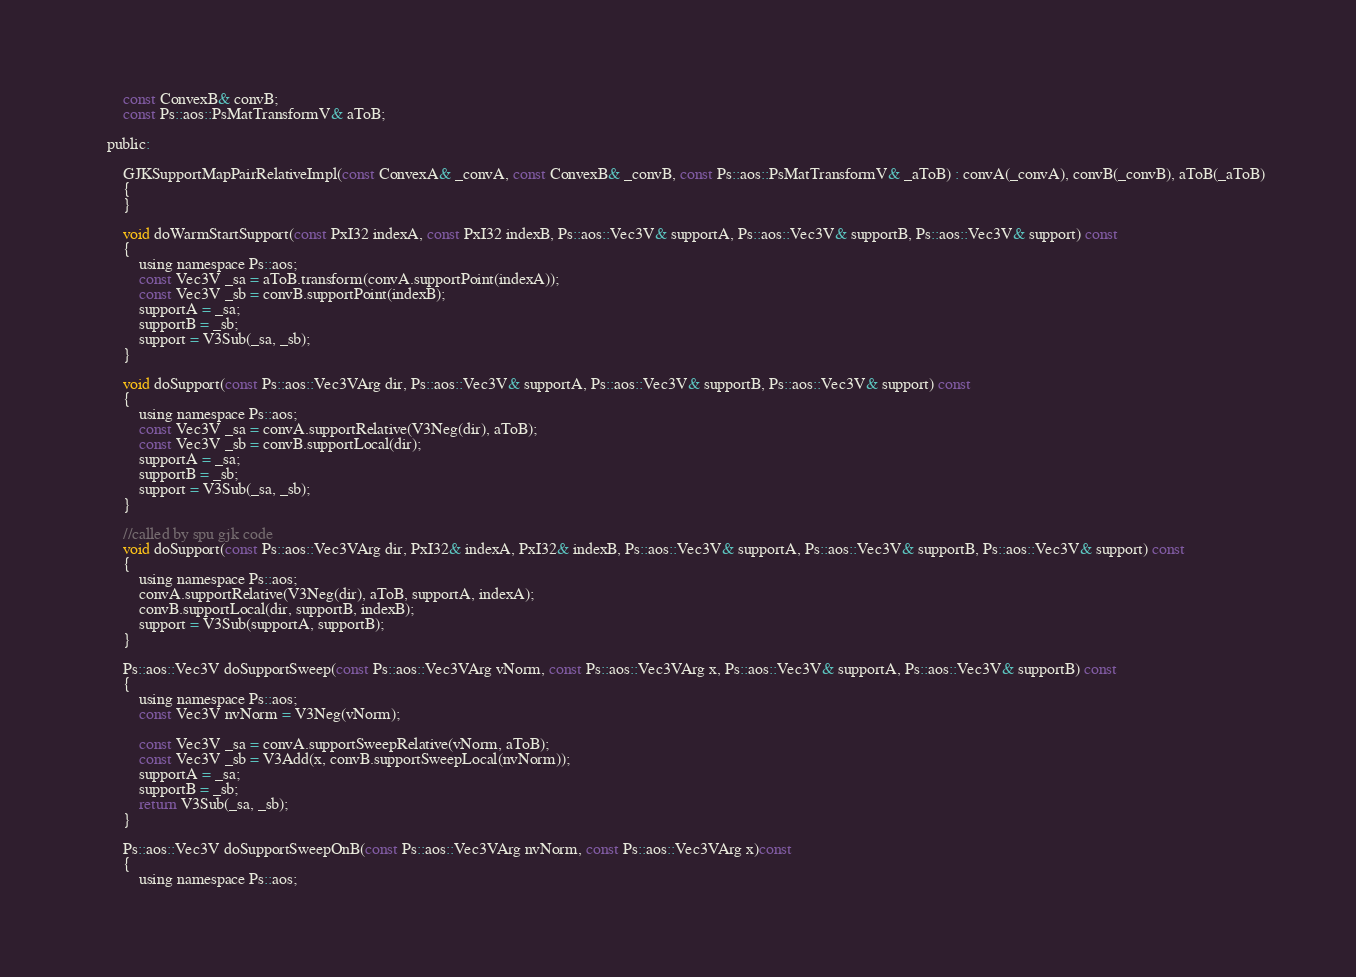<code> <loc_0><loc_0><loc_500><loc_500><_C_>		const ConvexB& convB;
		const Ps::aos::PsMatTransformV& aToB;

	public:

		GJKSupportMapPairRelativeImpl(const ConvexA& _convA, const ConvexB& _convB, const Ps::aos::PsMatTransformV& _aToB) : convA(_convA), convB(_convB), aToB(_aToB)
		{
		} 

		void doWarmStartSupport(const PxI32 indexA, const PxI32 indexB, Ps::aos::Vec3V& supportA, Ps::aos::Vec3V& supportB, Ps::aos::Vec3V& support) const
		{
			using namespace Ps::aos;
			const Vec3V _sa = aToB.transform(convA.supportPoint(indexA));
			const Vec3V _sb = convB.supportPoint(indexB);
			supportA = _sa;
			supportB = _sb;
			support = V3Sub(_sa, _sb);
		}

		void doSupport(const Ps::aos::Vec3VArg dir, Ps::aos::Vec3V& supportA, Ps::aos::Vec3V& supportB, Ps::aos::Vec3V& support) const
		{
			using namespace Ps::aos;
			const Vec3V _sa = convA.supportRelative(V3Neg(dir), aToB);
			const Vec3V _sb = convB.supportLocal(dir);
			supportA = _sa;
			supportB = _sb;
			support = V3Sub(_sa, _sb);
		}

		//called by spu gjk code
		void doSupport(const Ps::aos::Vec3VArg dir, PxI32& indexA, PxI32& indexB, Ps::aos::Vec3V& supportA, Ps::aos::Vec3V& supportB, Ps::aos::Vec3V& support) const
		{
			using namespace Ps::aos;
			convA.supportRelative(V3Neg(dir), aToB, supportA, indexA);
			convB.supportLocal(dir, supportB, indexB);
			support = V3Sub(supportA, supportB);
		}

		Ps::aos::Vec3V doSupportSweep(const Ps::aos::Vec3VArg vNorm, const Ps::aos::Vec3VArg x, Ps::aos::Vec3V& supportA, Ps::aos::Vec3V& supportB) const
		{
			using namespace Ps::aos;
			const Vec3V nvNorm = V3Neg(vNorm);

			const Vec3V _sa = convA.supportSweepRelative(vNorm, aToB);
			const Vec3V _sb = V3Add(x, convB.supportSweepLocal(nvNorm));
			supportA = _sa;
			supportB = _sb;
			return V3Sub(_sa, _sb);
		}

		Ps::aos::Vec3V doSupportSweepOnB(const Ps::aos::Vec3VArg nvNorm, const Ps::aos::Vec3VArg x)const 
		{
			using namespace Ps::aos;</code> 